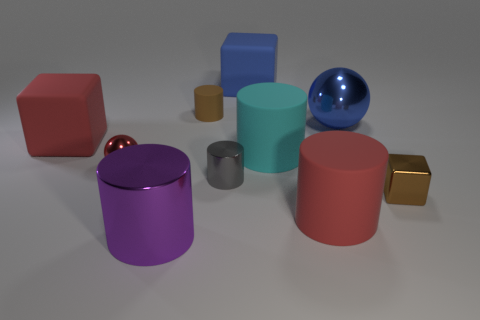Does the big object behind the brown rubber object have the same material as the small red thing?
Provide a succinct answer. No. How many metal spheres are right of the red cylinder and to the left of the big blue block?
Offer a terse response. 0. What size is the metal cylinder on the right side of the tiny matte cylinder that is right of the large purple metallic cylinder?
Offer a very short reply. Small. Are there more small brown things than small metallic objects?
Provide a short and direct response. No. There is a ball on the left side of the red rubber cylinder; is its color the same as the matte object behind the brown cylinder?
Give a very brief answer. No. There is a big cylinder to the left of the blue matte thing; are there any objects right of it?
Your answer should be compact. Yes. Are there fewer big blocks right of the small red shiny ball than things right of the red block?
Provide a succinct answer. Yes. Are the tiny thing behind the blue metal sphere and the large blue object that is to the left of the cyan object made of the same material?
Keep it short and to the point. Yes. How many big objects are purple cylinders or metal spheres?
Provide a succinct answer. 2. What is the shape of the tiny brown thing that is made of the same material as the blue block?
Make the answer very short. Cylinder. 